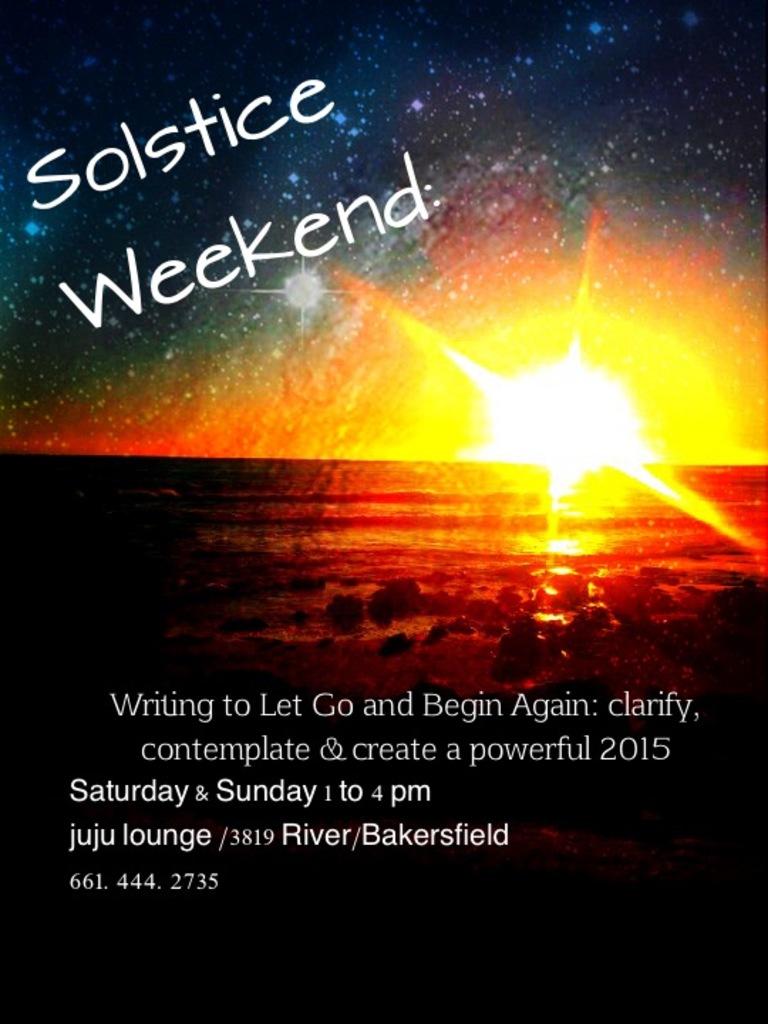What year does this refer to?
Your answer should be very brief. 2015. 